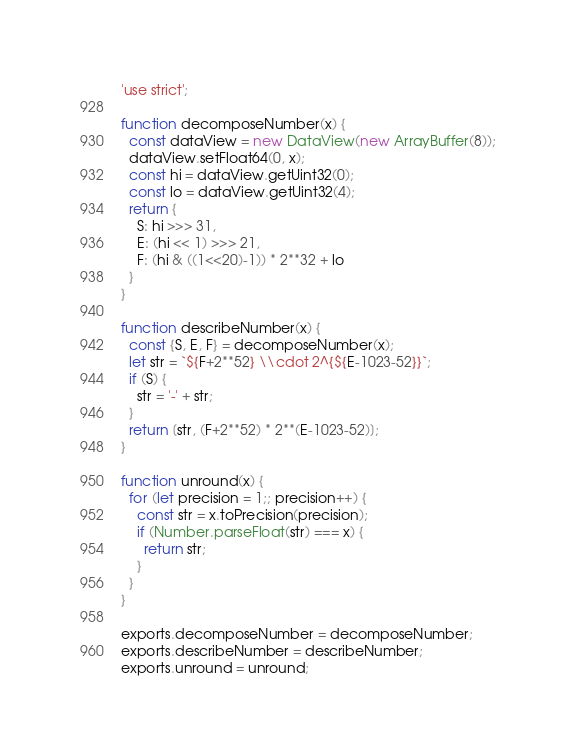Convert code to text. <code><loc_0><loc_0><loc_500><loc_500><_JavaScript_>'use strict';

function decomposeNumber(x) {
  const dataView = new DataView(new ArrayBuffer(8));
  dataView.setFloat64(0, x);
  const hi = dataView.getUint32(0);
  const lo = dataView.getUint32(4);
  return {
    S: hi >>> 31, 
    E: (hi << 1) >>> 21, 
    F: (hi & ((1<<20)-1)) * 2**32 + lo
  }
}

function describeNumber(x) {
  const {S, E, F} = decomposeNumber(x);
  let str = `${F+2**52} \\cdot 2^{${E-1023-52}}`;
  if (S) {
    str = '-' + str;
  }
  return [str, (F+2**52) * 2**(E-1023-52)];
}

function unround(x) {
  for (let precision = 1;; precision++) {
    const str = x.toPrecision(precision);
    if (Number.parseFloat(str) === x) {
      return str;
    }
  }
}

exports.decomposeNumber = decomposeNumber;
exports.describeNumber = describeNumber;
exports.unround = unround;
</code> 